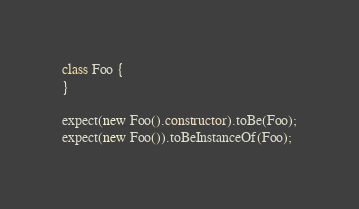<code> <loc_0><loc_0><loc_500><loc_500><_JavaScript_>class Foo {
}

expect(new Foo().constructor).toBe(Foo);
expect(new Foo()).toBeInstanceOf(Foo);
</code> 